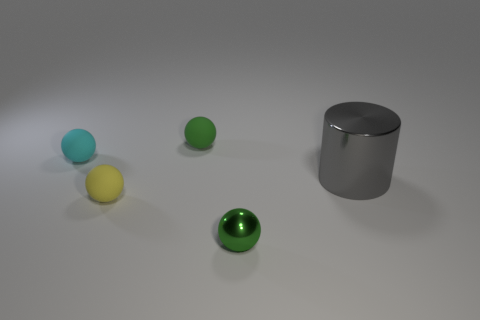Subtract 1 spheres. How many spheres are left? 3 Subtract all brown balls. Subtract all red blocks. How many balls are left? 4 Add 3 brown things. How many objects exist? 8 Subtract all cylinders. How many objects are left? 4 Add 2 yellow things. How many yellow things are left? 3 Add 2 gray metal cylinders. How many gray metal cylinders exist? 3 Subtract 1 yellow balls. How many objects are left? 4 Subtract all small gray metal cylinders. Subtract all small balls. How many objects are left? 1 